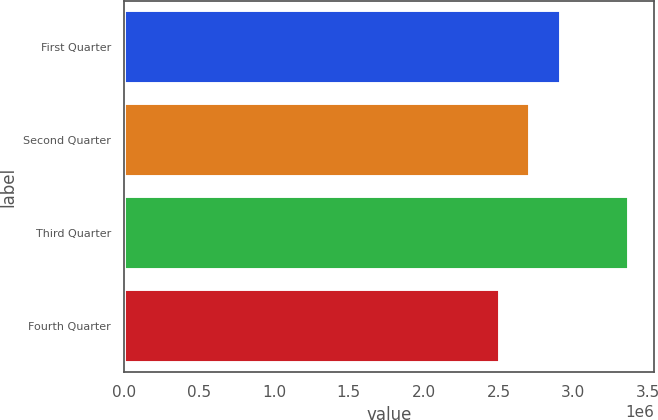<chart> <loc_0><loc_0><loc_500><loc_500><bar_chart><fcel>First Quarter<fcel>Second Quarter<fcel>Third Quarter<fcel>Fourth Quarter<nl><fcel>2.92009e+06<fcel>2.71323e+06<fcel>3.37141e+06<fcel>2.50852e+06<nl></chart> 